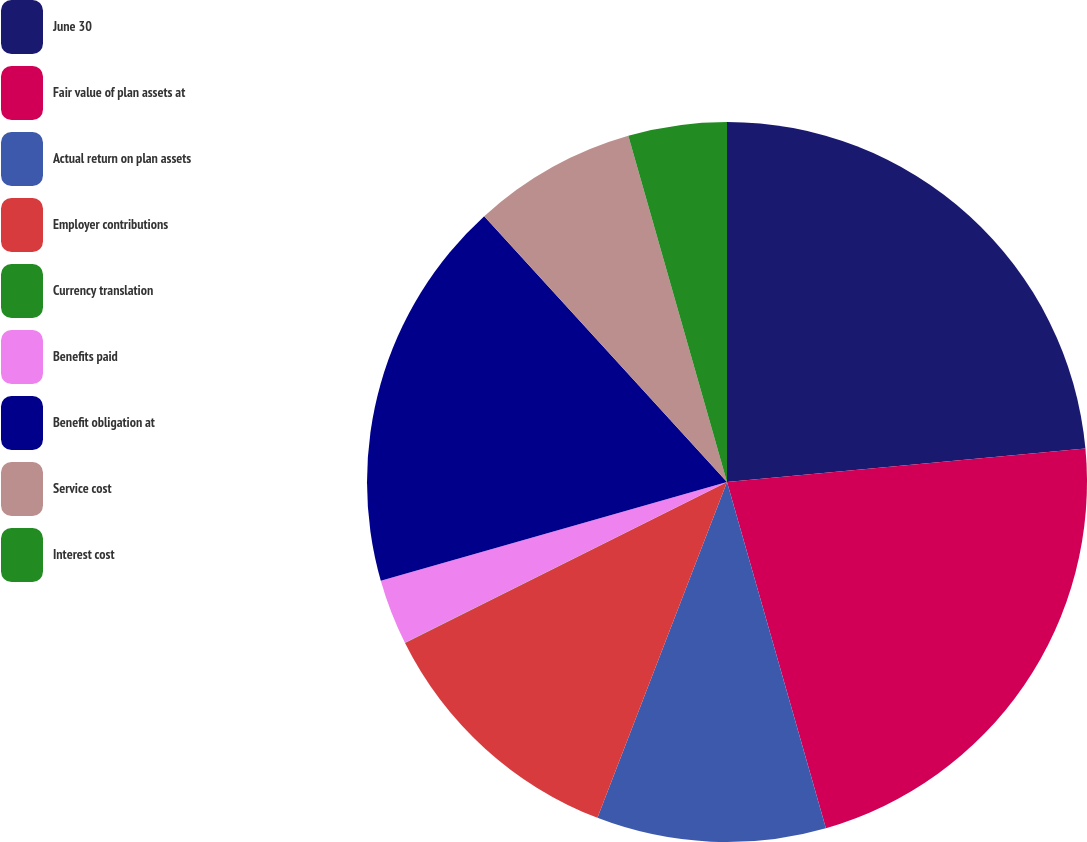Convert chart. <chart><loc_0><loc_0><loc_500><loc_500><pie_chart><fcel>June 30<fcel>Fair value of plan assets at<fcel>Actual return on plan assets<fcel>Employer contributions<fcel>Currency translation<fcel>Benefits paid<fcel>Benefit obligation at<fcel>Service cost<fcel>Interest cost<nl><fcel>23.52%<fcel>22.05%<fcel>10.29%<fcel>11.76%<fcel>0.01%<fcel>2.95%<fcel>17.64%<fcel>7.36%<fcel>4.42%<nl></chart> 